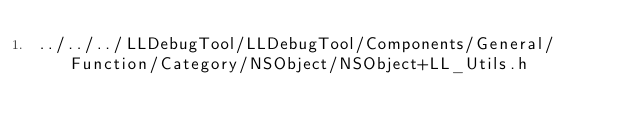Convert code to text. <code><loc_0><loc_0><loc_500><loc_500><_C_>../../../LLDebugTool/LLDebugTool/Components/General/Function/Category/NSObject/NSObject+LL_Utils.h</code> 